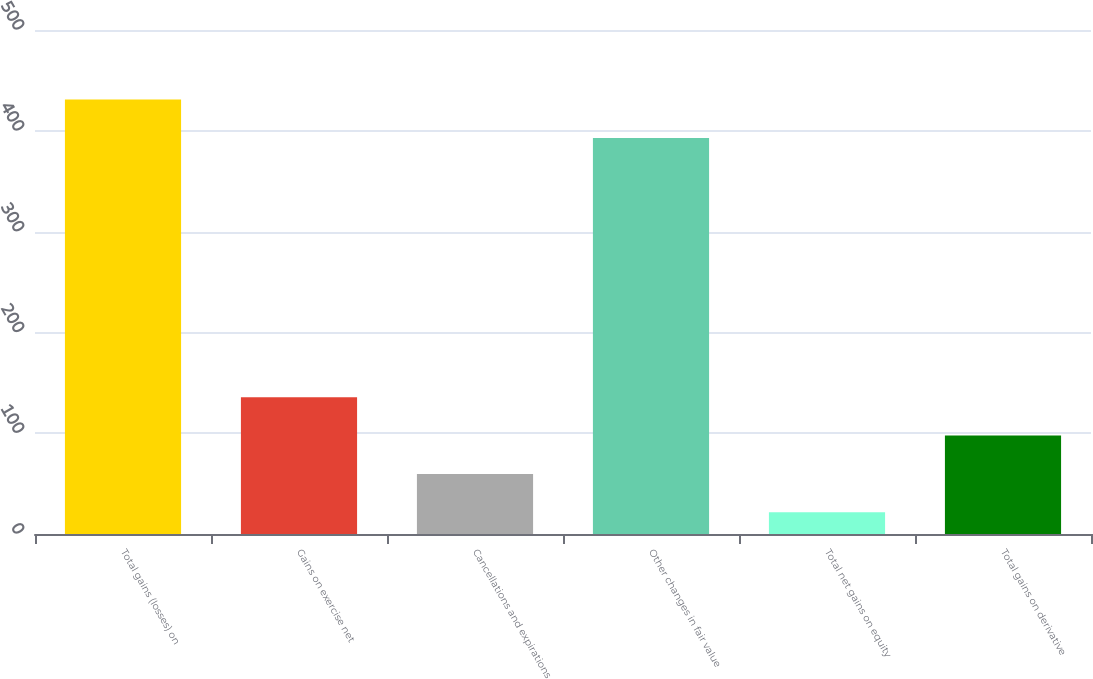<chart> <loc_0><loc_0><loc_500><loc_500><bar_chart><fcel>Total gains (losses) on<fcel>Gains on exercise net<fcel>Cancellations and expirations<fcel>Other changes in fair value<fcel>Total net gains on equity<fcel>Total gains on derivative<nl><fcel>430.97<fcel>135.71<fcel>59.57<fcel>392.9<fcel>21.5<fcel>97.64<nl></chart> 